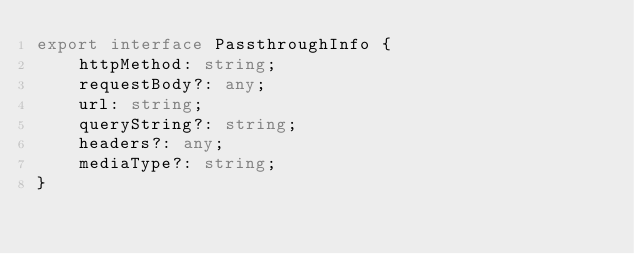Convert code to text. <code><loc_0><loc_0><loc_500><loc_500><_TypeScript_>export interface PassthroughInfo {
    httpMethod: string;
    requestBody?: any;
    url: string;
    queryString?: string;
    headers?: any;
    mediaType?: string;
}</code> 